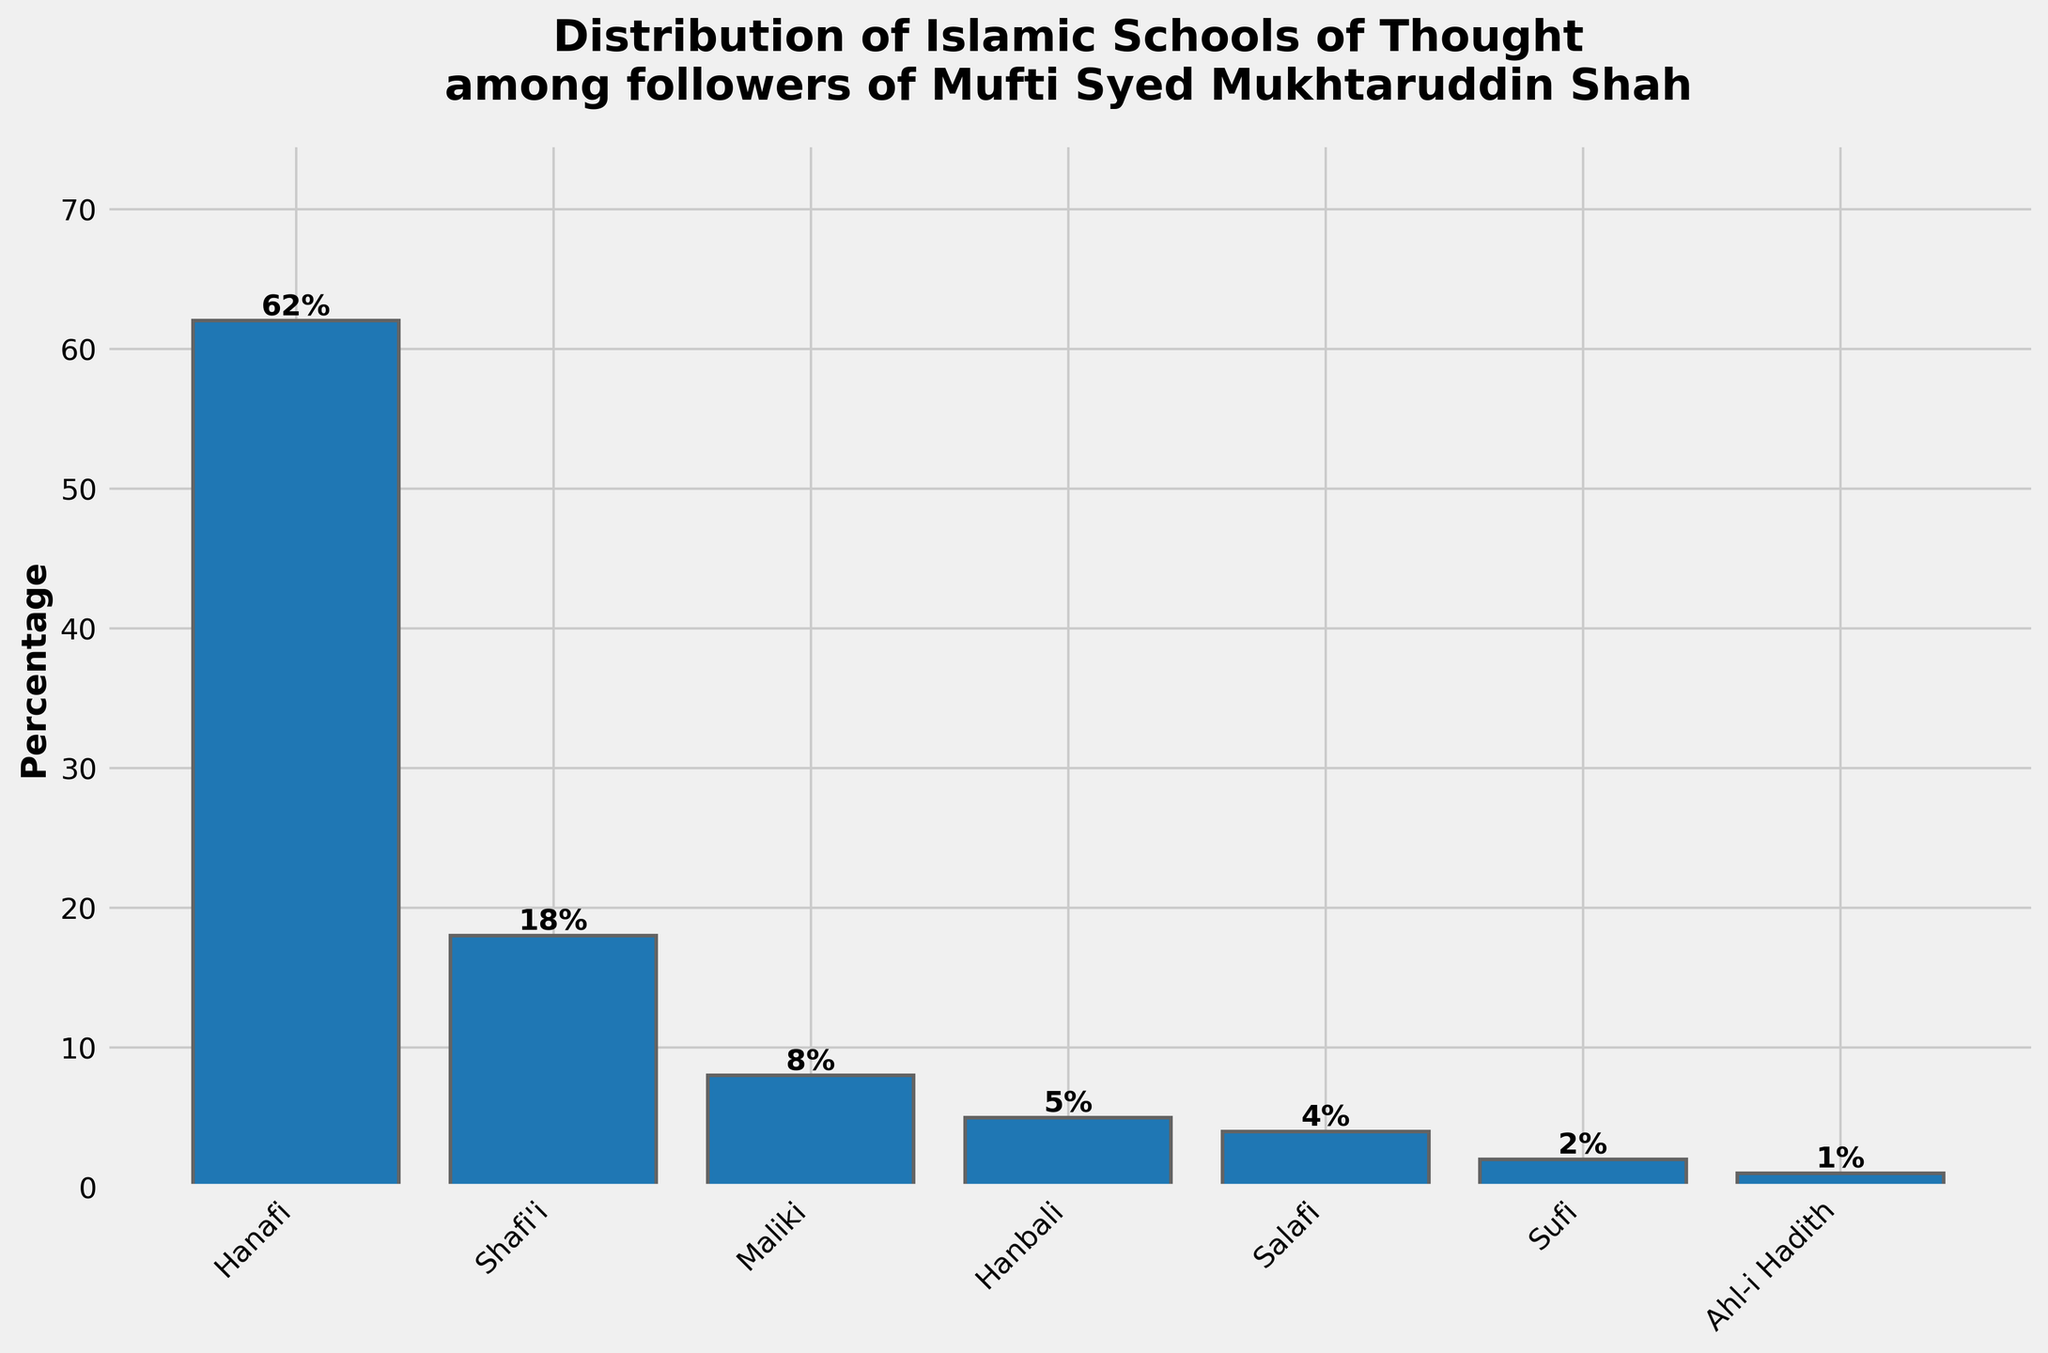Which Islamic school of thought has the highest percentage among followers of Mufti Syed Mukhtaruddin Shah? The figure shows a bar chart with different Islamic schools of thought and their respective percentages. The tallest bar represents the school with the highest percentage.
Answer: Hanafi What is the combined percentage of Maliki and Hanbali followers? To find the combined percentage, add the individual percentages of Maliki and Hanbali followers. From the figure, Maliki has 8% and Hanbali has 5%. The sum is 8% + 5% = 13%.
Answer: 13% Which school of thought has the lowest representation among the followers? The bar representing the lowest value in the bar chart indicates the school of thought with the lowest percentage. The shortest bar corresponds to the lowest percentage.
Answer: Ahl-i Hadith How much higher is the percentage of Hanafi followers compared to Shafi'i followers? Subtract the percentage of Shafi'i followers from the percentage of Hanafi followers. According to the figure, Hanafi has 62% and Shafi'i has 18%. The difference is 62% - 18% = 44%.
Answer: 44% Rank the Islamic schools of thought based on their percentage from highest to lowest. Observe the heights of the bars from the tallest to the shortest and list the schools of thought accordingly.
Answer: Hanafi, Shafi'i, Maliki, Hanbali, Salafi, Sufi, Ahl-i Hadith What is the average percentage of followers across all the schools of thought? Calculate the average by summing the percentages of all the schools of thought and then dividing by the number of schools. The sum is 62% + 18% + 8% + 5% + 4% + 2% + 1% = 100%. There are 7 schools of thought. The average is 100% / 7 = approximately 14.29%.
Answer: 14.29% How does the percentage of Salafi followers compare to the percentage of Sufi followers? Compare the heights of the bars for Salafi and Sufi followers. From the figure, Salafi has 4% and Sufi has 2%. Salafi percentage is higher by 2%.
Answer: Salafi has 2% more Is the percentage of Shafi'i followers more than double the percentage of Maliki followers? Double the percentage of Maliki followers and compare it to the percentage of Shafi'i followers. Maliki has 8%, and double that is 16%. Shafi'i has 18%, which is more than 16%.
Answer: Yes What percentage of followers adhere to non-Hanafi schools of thought? Subtract the percentage of Hanafi followers from 100% to get the percentage of non-Hanafi followers. Hanafi has 62%, so non-Hanafi is 100% - 62% = 38%.
Answer: 38% If you were to group together Salafi, Sufi, and Ahl-i Hadith followers, what would their combined percentage be? Add the percentages of Salafi, Sufi, and Ahl-i Hadith followers. According to the figure, Salafi has 4%, Sufi has 2%, and Ahl-i Hadith has 1%. The sum is 4% + 2% + 1% = 7%.
Answer: 7% 